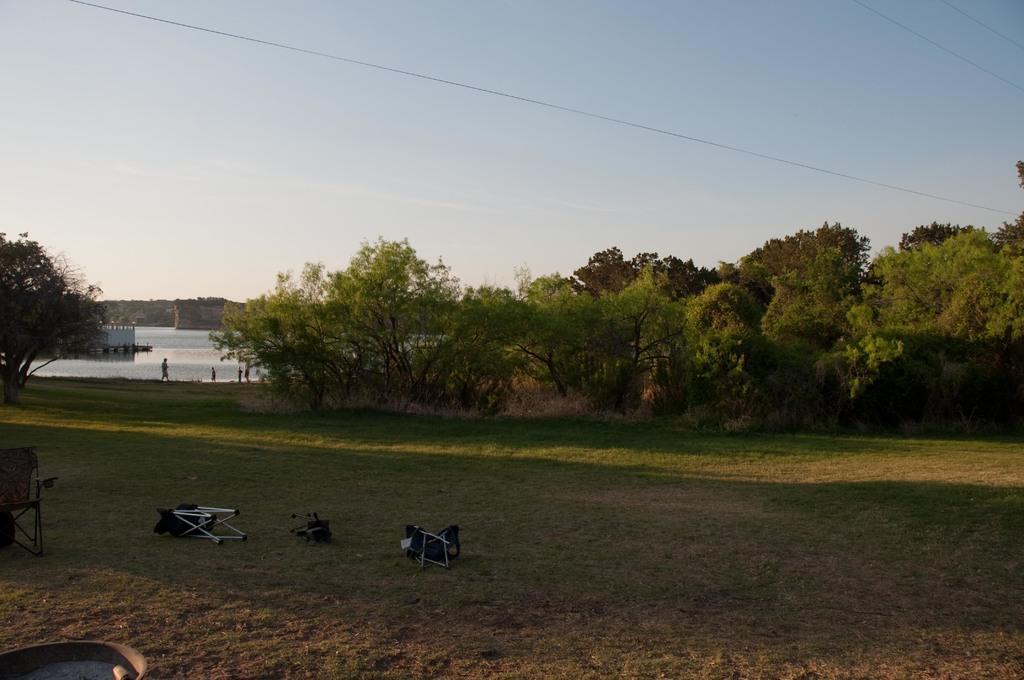Can you describe this image briefly? In this picture we can see grass and three chairs at the bottom, in the background there is water, we can see trees and some people in the middle, there is the sky at the top of the picture. 